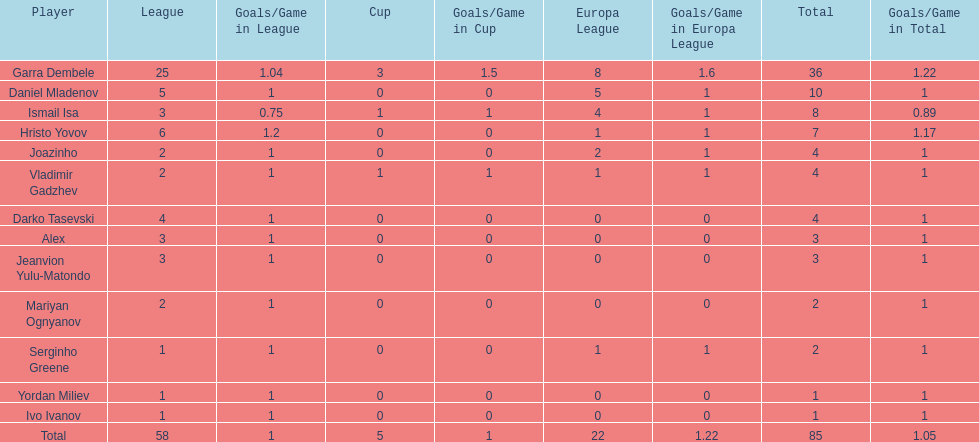Would you mind parsing the complete table? {'header': ['Player', 'League', 'Goals/Game in League', 'Cup', 'Goals/Game in Cup', 'Europa League', 'Goals/Game in Europa League', 'Total', 'Goals/Game in Total'], 'rows': [['Garra Dembele', '25', '1.04', '3', '1.5', '8', '1.6', '36', '1.22'], ['Daniel Mladenov', '5', '1', '0', '0', '5', '1', '10', '1'], ['Ismail Isa', '3', '0.75', '1', '1', '4', '1', '8', '0.89'], ['Hristo Yovov', '6', '1.2', '0', '0', '1', '1', '7', '1.17'], ['Joazinho', '2', '1', '0', '0', '2', '1', '4', '1'], ['Vladimir Gadzhev', '2', '1', '1', '1', '1', '1', '4', '1'], ['Darko Tasevski', '4', '1', '0', '0', '0', '0', '4', '1'], ['Alex', '3', '1', '0', '0', '0', '0', '3', '1'], ['Jeanvion Yulu-Matondo', '3', '1', '0', '0', '0', '0', '3', '1'], ['Mariyan Ognyanov', '2', '1', '0', '0', '0', '0', '2', '1'], ['Serginho Greene', '1', '1', '0', '0', '1', '1', '2', '1'], ['Yordan Miliev', '1', '1', '0', '0', '0', '0', '1', '1'], ['Ivo Ivanov', '1', '1', '0', '0', '0', '0', '1', '1'], ['Total', '58', '1', '5', '1', '22', '1.22', '85', '1.05']]} Which player is in the same league as joazinho and vladimir gadzhev? Mariyan Ognyanov. 